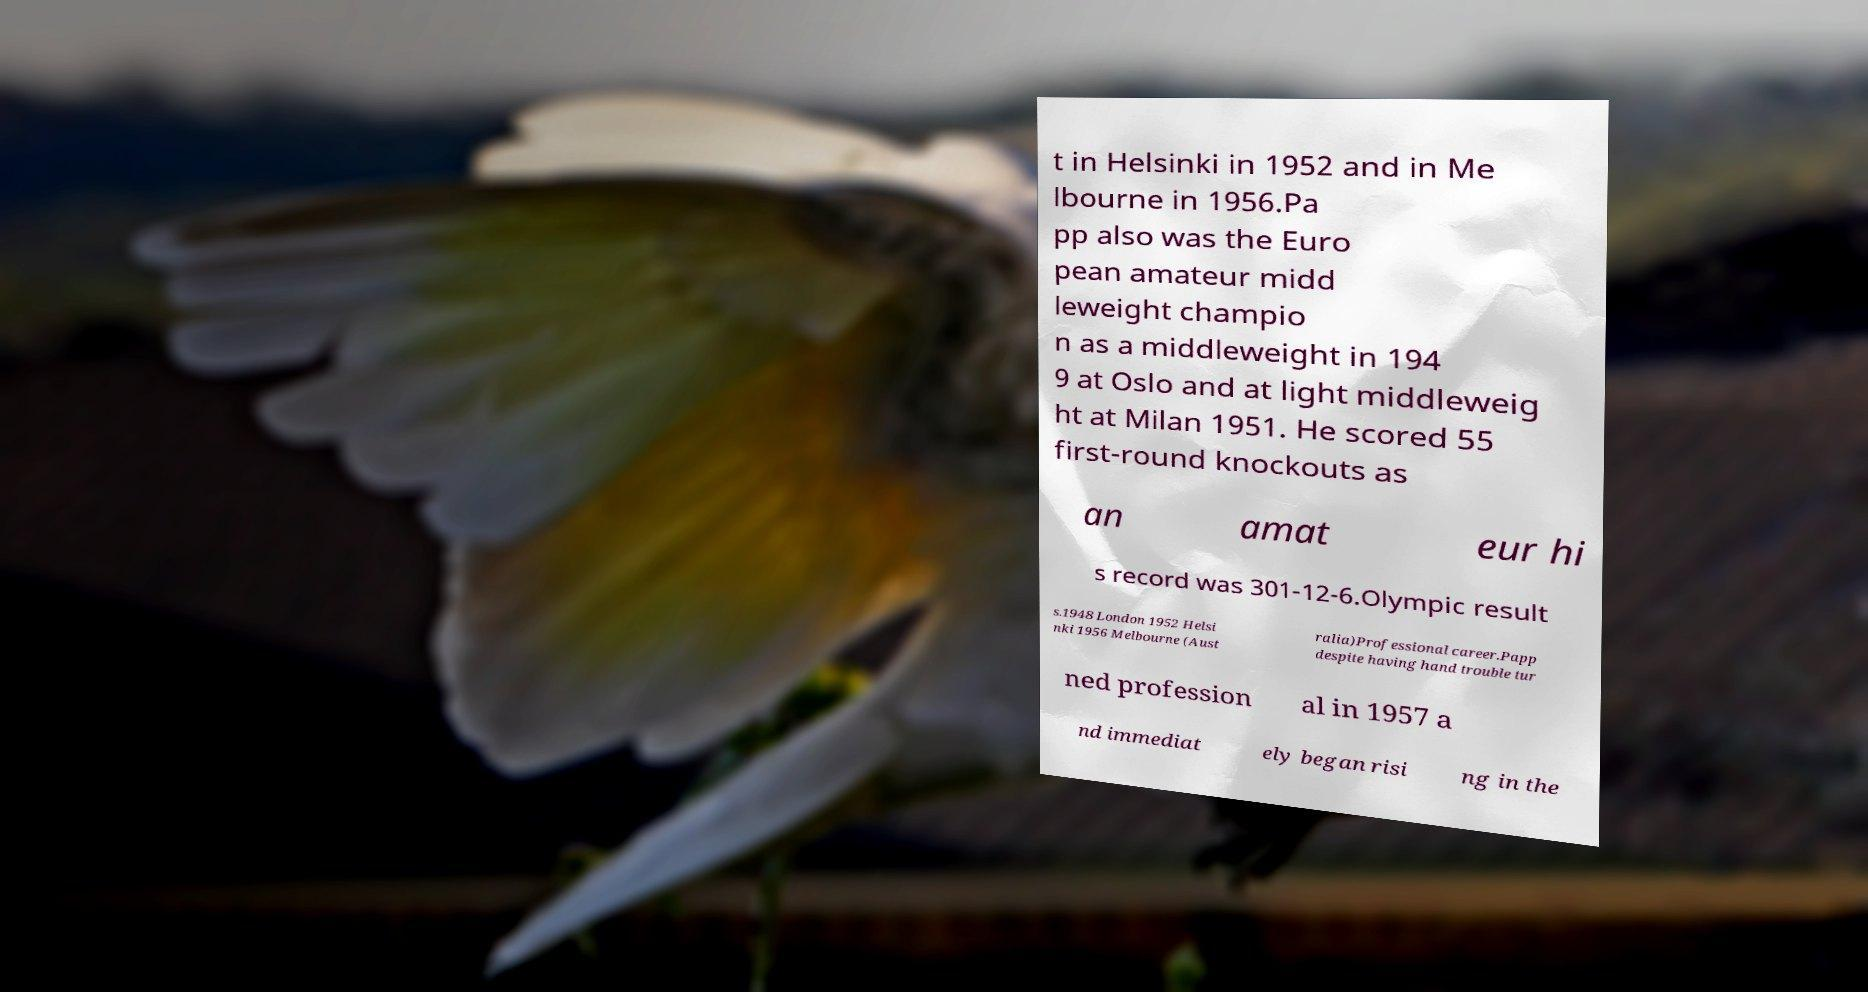Could you extract and type out the text from this image? t in Helsinki in 1952 and in Me lbourne in 1956.Pa pp also was the Euro pean amateur midd leweight champio n as a middleweight in 194 9 at Oslo and at light middleweig ht at Milan 1951. He scored 55 first-round knockouts as an amat eur hi s record was 301-12-6.Olympic result s.1948 London 1952 Helsi nki 1956 Melbourne (Aust ralia)Professional career.Papp despite having hand trouble tur ned profession al in 1957 a nd immediat ely began risi ng in the 